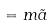<formula> <loc_0><loc_0><loc_500><loc_500>= m \tilde { a }</formula> 